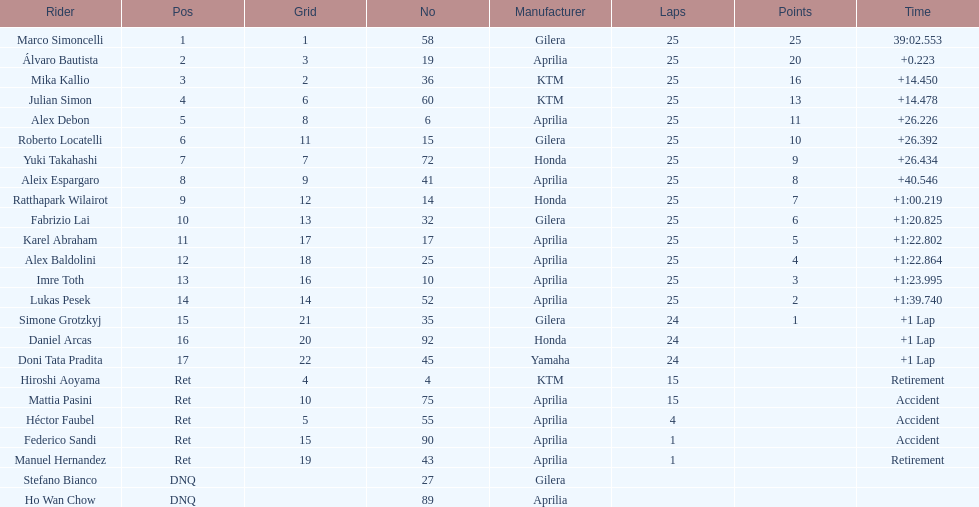How many riders manufacturer is honda? 3. 